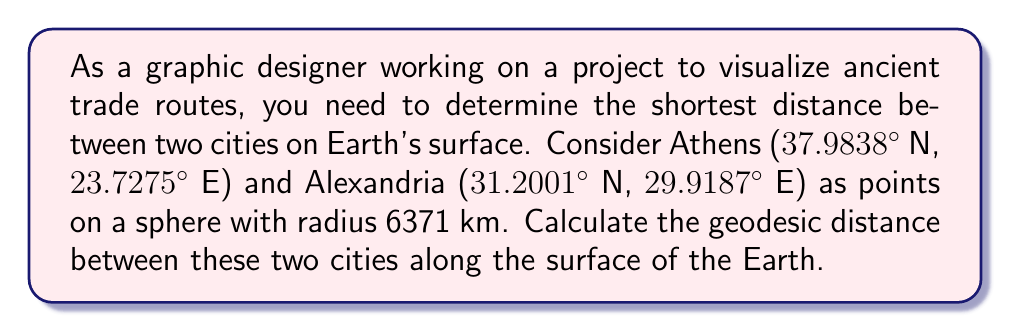Solve this math problem. To solve this problem, we'll use the spherical law of cosines to calculate the central angle between the two points, and then use that angle to determine the geodesic distance along the surface of the sphere.

Step 1: Convert the latitudes and longitudes to radians.
Athens: $\phi_1 = 37.9838° \times \frac{\pi}{180} = 0.6629$ rad, $\lambda_1 = 23.7275° \times \frac{\pi}{180} = 0.4141$ rad
Alexandria: $\phi_2 = 31.2001° \times \frac{\pi}{180} = 0.5446$ rad, $\lambda_2 = 29.9187° \times \frac{\pi}{180} = 0.5222$ rad

Step 2: Calculate the central angle $\theta$ using the spherical law of cosines:
$$\cos(\theta) = \sin(\phi_1)\sin(\phi_2) + \cos(\phi_1)\cos(\phi_2)\cos(\lambda_2 - \lambda_1)$$

Substituting the values:
$$\cos(\theta) = \sin(0.6629)\sin(0.5446) + \cos(0.6629)\cos(0.5446)\cos(0.5222 - 0.4141)$$
$$\cos(\theta) = 0.9829$$

Step 3: Calculate $\theta$ by taking the inverse cosine:
$$\theta = \arccos(0.9829) = 0.1849 \text{ radians}$$

Step 4: Calculate the geodesic distance $d$ using the formula:
$$d = R\theta$$
where $R$ is the radius of the Earth (6371 km).

$$d = 6371 \times 0.1849 = 1178.0 \text{ km}$$

Therefore, the geodesic distance between Athens and Alexandria is approximately 1178.0 km.
Answer: The geodesic distance between Athens and Alexandria is approximately 1178.0 km. 